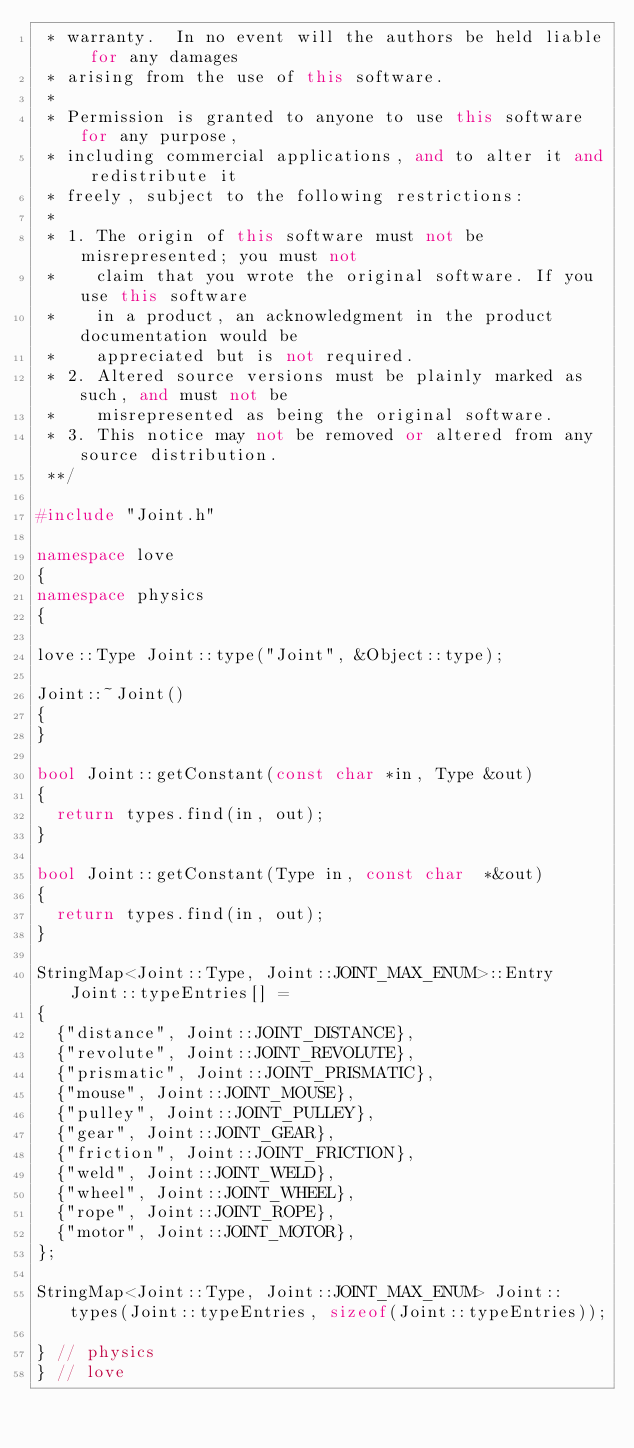Convert code to text. <code><loc_0><loc_0><loc_500><loc_500><_C++_> * warranty.  In no event will the authors be held liable for any damages
 * arising from the use of this software.
 *
 * Permission is granted to anyone to use this software for any purpose,
 * including commercial applications, and to alter it and redistribute it
 * freely, subject to the following restrictions:
 *
 * 1. The origin of this software must not be misrepresented; you must not
 *    claim that you wrote the original software. If you use this software
 *    in a product, an acknowledgment in the product documentation would be
 *    appreciated but is not required.
 * 2. Altered source versions must be plainly marked as such, and must not be
 *    misrepresented as being the original software.
 * 3. This notice may not be removed or altered from any source distribution.
 **/

#include "Joint.h"

namespace love
{
namespace physics
{

love::Type Joint::type("Joint", &Object::type);

Joint::~Joint()
{
}

bool Joint::getConstant(const char *in, Type &out)
{
	return types.find(in, out);
}

bool Joint::getConstant(Type in, const char  *&out)
{
	return types.find(in, out);
}

StringMap<Joint::Type, Joint::JOINT_MAX_ENUM>::Entry Joint::typeEntries[] =
{
	{"distance", Joint::JOINT_DISTANCE},
	{"revolute", Joint::JOINT_REVOLUTE},
	{"prismatic", Joint::JOINT_PRISMATIC},
	{"mouse", Joint::JOINT_MOUSE},
	{"pulley", Joint::JOINT_PULLEY},
	{"gear", Joint::JOINT_GEAR},
	{"friction", Joint::JOINT_FRICTION},
	{"weld", Joint::JOINT_WELD},
	{"wheel", Joint::JOINT_WHEEL},
	{"rope", Joint::JOINT_ROPE},
	{"motor", Joint::JOINT_MOTOR},
};

StringMap<Joint::Type, Joint::JOINT_MAX_ENUM> Joint::types(Joint::typeEntries, sizeof(Joint::typeEntries));

} // physics
} // love
</code> 